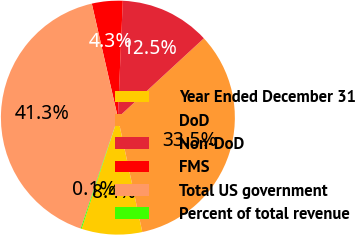Convert chart to OTSL. <chart><loc_0><loc_0><loc_500><loc_500><pie_chart><fcel>Year Ended December 31<fcel>DoD<fcel>Non-DoD<fcel>FMS<fcel>Total US government<fcel>Percent of total revenue<nl><fcel>8.36%<fcel>33.51%<fcel>12.47%<fcel>4.25%<fcel>41.27%<fcel>0.13%<nl></chart> 